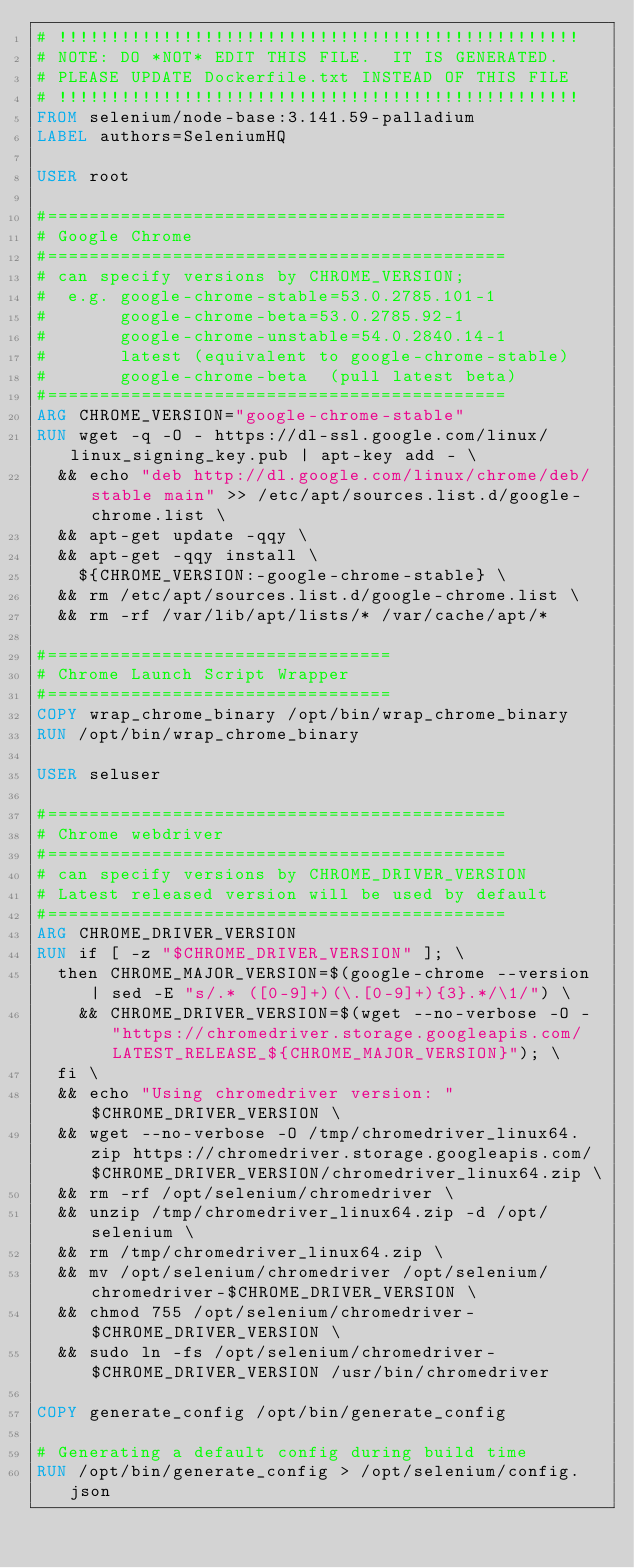Convert code to text. <code><loc_0><loc_0><loc_500><loc_500><_Dockerfile_># !!!!!!!!!!!!!!!!!!!!!!!!!!!!!!!!!!!!!!!!!!!!!!!!!!
# NOTE: DO *NOT* EDIT THIS FILE.  IT IS GENERATED.
# PLEASE UPDATE Dockerfile.txt INSTEAD OF THIS FILE
# !!!!!!!!!!!!!!!!!!!!!!!!!!!!!!!!!!!!!!!!!!!!!!!!!!
FROM selenium/node-base:3.141.59-palladium
LABEL authors=SeleniumHQ

USER root

#============================================
# Google Chrome
#============================================
# can specify versions by CHROME_VERSION;
#  e.g. google-chrome-stable=53.0.2785.101-1
#       google-chrome-beta=53.0.2785.92-1
#       google-chrome-unstable=54.0.2840.14-1
#       latest (equivalent to google-chrome-stable)
#       google-chrome-beta  (pull latest beta)
#============================================
ARG CHROME_VERSION="google-chrome-stable"
RUN wget -q -O - https://dl-ssl.google.com/linux/linux_signing_key.pub | apt-key add - \
  && echo "deb http://dl.google.com/linux/chrome/deb/ stable main" >> /etc/apt/sources.list.d/google-chrome.list \
  && apt-get update -qqy \
  && apt-get -qqy install \
    ${CHROME_VERSION:-google-chrome-stable} \
  && rm /etc/apt/sources.list.d/google-chrome.list \
  && rm -rf /var/lib/apt/lists/* /var/cache/apt/*

#=================================
# Chrome Launch Script Wrapper
#=================================
COPY wrap_chrome_binary /opt/bin/wrap_chrome_binary
RUN /opt/bin/wrap_chrome_binary

USER seluser

#============================================
# Chrome webdriver
#============================================
# can specify versions by CHROME_DRIVER_VERSION
# Latest released version will be used by default
#============================================
ARG CHROME_DRIVER_VERSION
RUN if [ -z "$CHROME_DRIVER_VERSION" ]; \
  then CHROME_MAJOR_VERSION=$(google-chrome --version | sed -E "s/.* ([0-9]+)(\.[0-9]+){3}.*/\1/") \
    && CHROME_DRIVER_VERSION=$(wget --no-verbose -O - "https://chromedriver.storage.googleapis.com/LATEST_RELEASE_${CHROME_MAJOR_VERSION}"); \
  fi \
  && echo "Using chromedriver version: "$CHROME_DRIVER_VERSION \
  && wget --no-verbose -O /tmp/chromedriver_linux64.zip https://chromedriver.storage.googleapis.com/$CHROME_DRIVER_VERSION/chromedriver_linux64.zip \
  && rm -rf /opt/selenium/chromedriver \
  && unzip /tmp/chromedriver_linux64.zip -d /opt/selenium \
  && rm /tmp/chromedriver_linux64.zip \
  && mv /opt/selenium/chromedriver /opt/selenium/chromedriver-$CHROME_DRIVER_VERSION \
  && chmod 755 /opt/selenium/chromedriver-$CHROME_DRIVER_VERSION \
  && sudo ln -fs /opt/selenium/chromedriver-$CHROME_DRIVER_VERSION /usr/bin/chromedriver

COPY generate_config /opt/bin/generate_config

# Generating a default config during build time
RUN /opt/bin/generate_config > /opt/selenium/config.json
</code> 